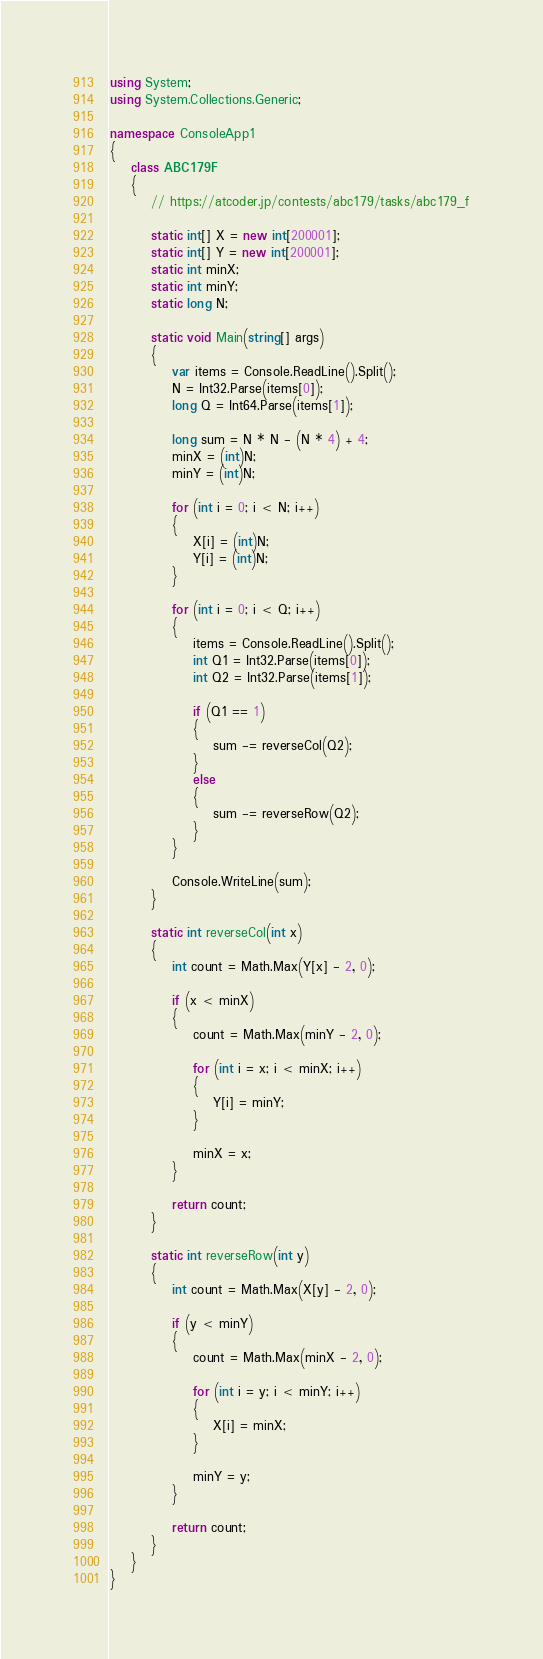Convert code to text. <code><loc_0><loc_0><loc_500><loc_500><_C#_>using System;
using System.Collections.Generic;

namespace ConsoleApp1
{
    class ABC179F
    {
        // https://atcoder.jp/contests/abc179/tasks/abc179_f

        static int[] X = new int[200001];
        static int[] Y = new int[200001];
        static int minX;
        static int minY;
        static long N;

        static void Main(string[] args)
        {
            var items = Console.ReadLine().Split();
            N = Int32.Parse(items[0]);
            long Q = Int64.Parse(items[1]);

            long sum = N * N - (N * 4) + 4;
            minX = (int)N;
            minY = (int)N;

            for (int i = 0; i < N; i++)
            {
                X[i] = (int)N;
                Y[i] = (int)N;
            }

            for (int i = 0; i < Q; i++)
            {
                items = Console.ReadLine().Split();
                int Q1 = Int32.Parse(items[0]);
                int Q2 = Int32.Parse(items[1]);

                if (Q1 == 1)
                {
                    sum -= reverseCol(Q2);
                }
                else
                {
                    sum -= reverseRow(Q2);
                }
            }

            Console.WriteLine(sum);
        }

        static int reverseCol(int x)
        {
            int count = Math.Max(Y[x] - 2, 0);

            if (x < minX)
            {
                count = Math.Max(minY - 2, 0);

                for (int i = x; i < minX; i++)
                {
                    Y[i] = minY;
                }

                minX = x;
            }

            return count;
        }

        static int reverseRow(int y)
        {
            int count = Math.Max(X[y] - 2, 0);

            if (y < minY)
            {
                count = Math.Max(minX - 2, 0);

                for (int i = y; i < minY; i++)
                {
                    X[i] = minX;
                }

                minY = y;
            }

            return count;
        }
    }
}
</code> 